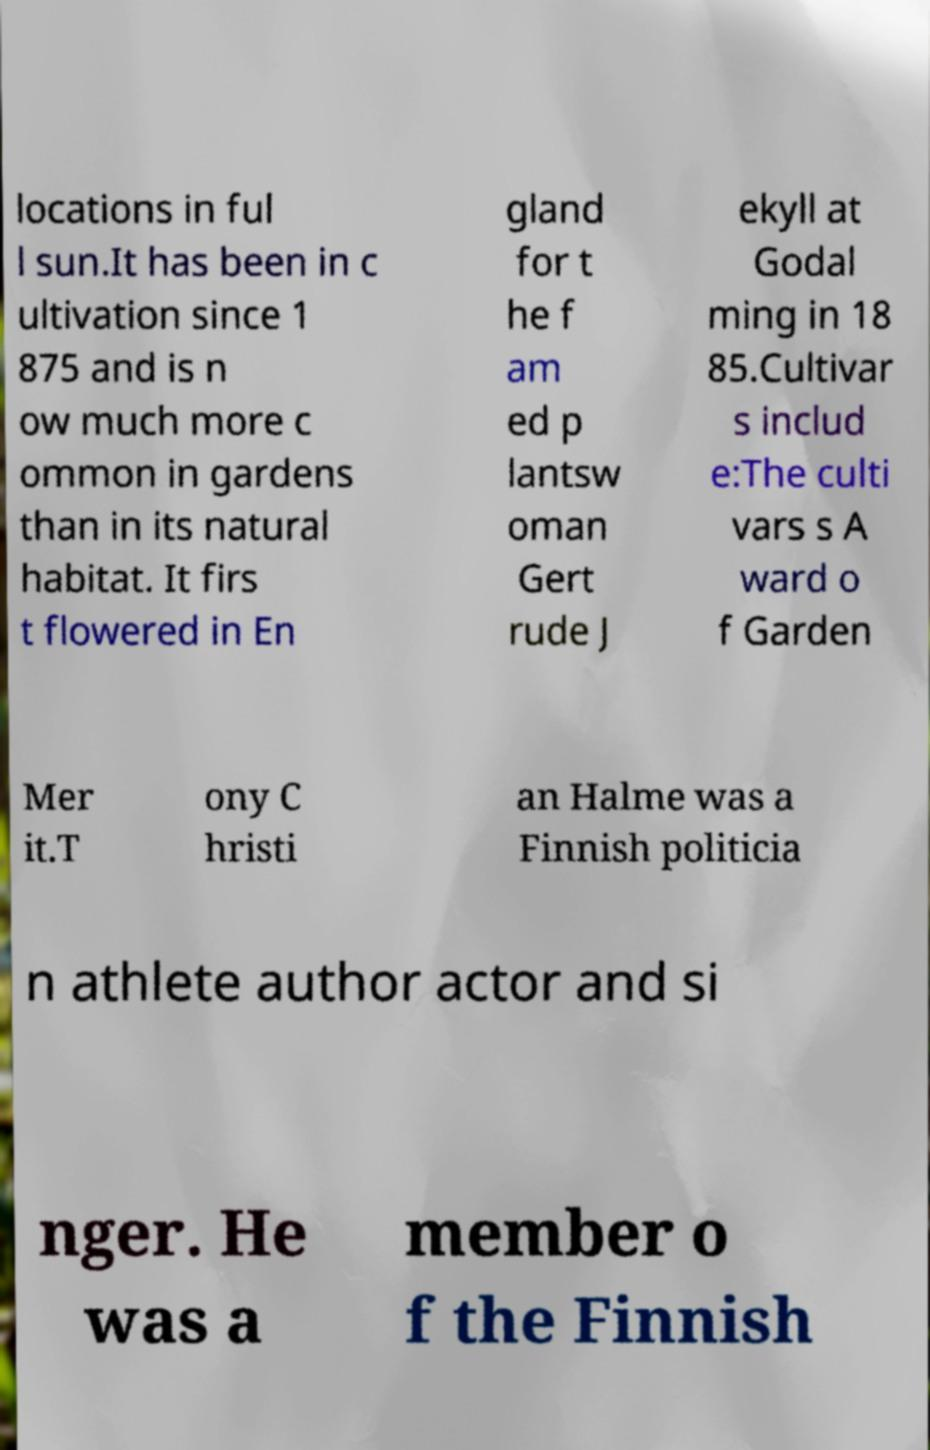Please read and relay the text visible in this image. What does it say? locations in ful l sun.It has been in c ultivation since 1 875 and is n ow much more c ommon in gardens than in its natural habitat. It firs t flowered in En gland for t he f am ed p lantsw oman Gert rude J ekyll at Godal ming in 18 85.Cultivar s includ e:The culti vars s A ward o f Garden Mer it.T ony C hristi an Halme was a Finnish politicia n athlete author actor and si nger. He was a member o f the Finnish 